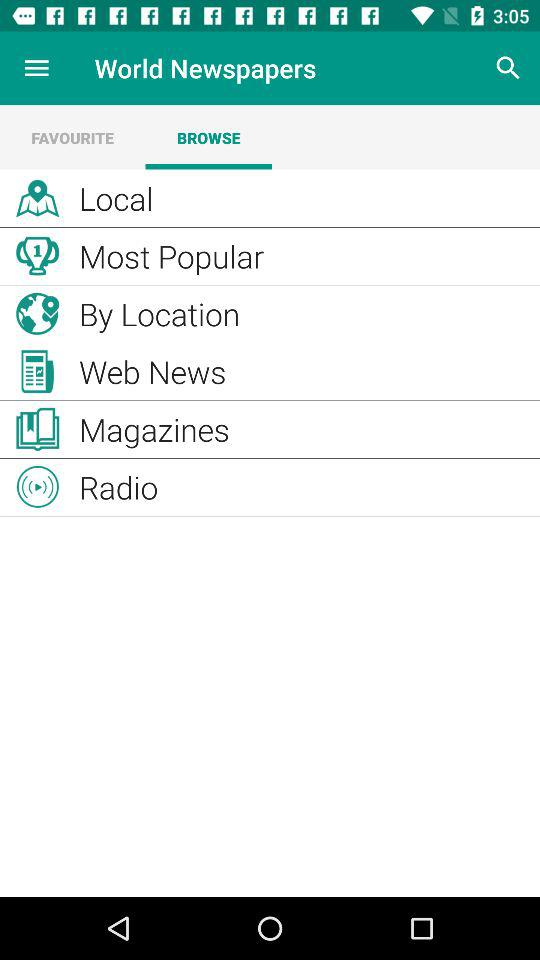Which tab am I on? You are on the "BROWSE" tab. 